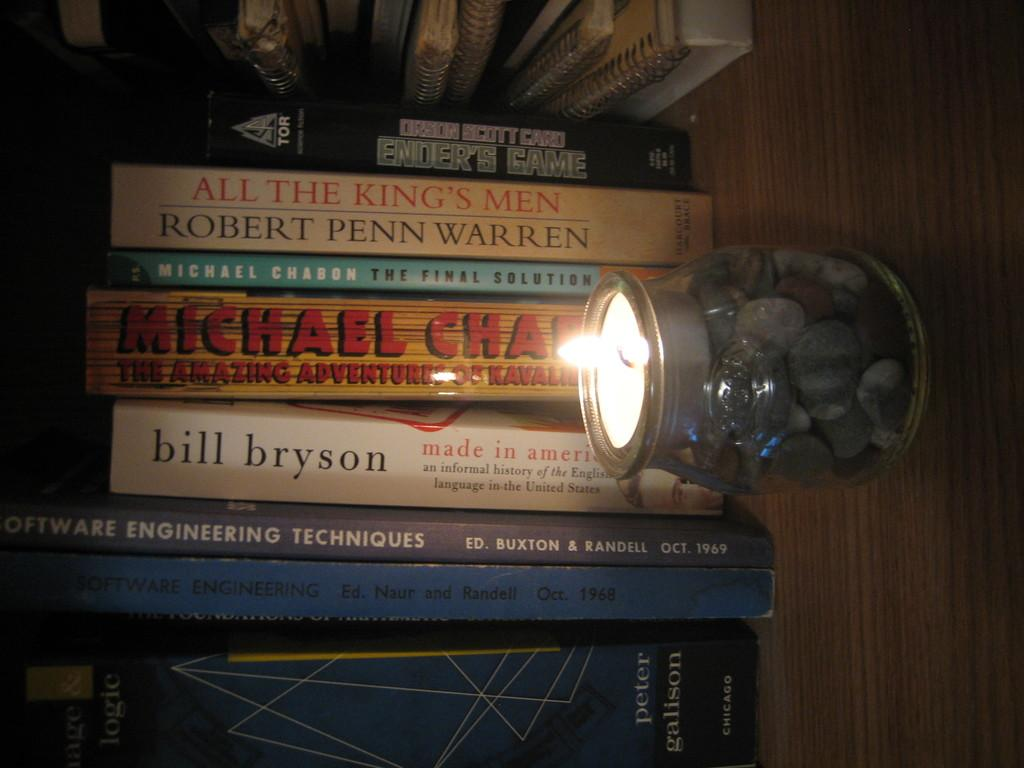<image>
Describe the image concisely. a stack of books with one of them being by bill bryson 